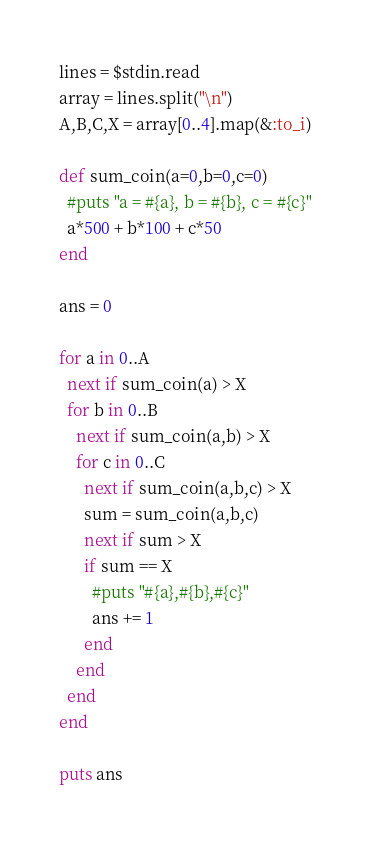Convert code to text. <code><loc_0><loc_0><loc_500><loc_500><_Ruby_>lines = $stdin.read
array = lines.split("\n")
A,B,C,X = array[0..4].map(&:to_i)

def sum_coin(a=0,b=0,c=0)
  #puts "a = #{a}, b = #{b}, c = #{c}"
  a*500 + b*100 + c*50
end

ans = 0

for a in 0..A
  next if sum_coin(a) > X
  for b in 0..B
    next if sum_coin(a,b) > X
    for c in 0..C
      next if sum_coin(a,b,c) > X
      sum = sum_coin(a,b,c)
      next if sum > X
      if sum == X
        #puts "#{a},#{b},#{c}"
        ans += 1
      end
    end
  end
end

puts ans
</code> 